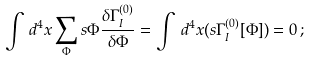Convert formula to latex. <formula><loc_0><loc_0><loc_500><loc_500>\int \, d ^ { 4 } x \sum _ { \Phi } s \Phi \frac { \delta \Gamma ^ { ( 0 ) } _ { I } } { \delta \Phi } = \int \, d ^ { 4 } x ( s \Gamma ^ { ( 0 ) } _ { I } [ \Phi ] ) = 0 \, ;</formula> 